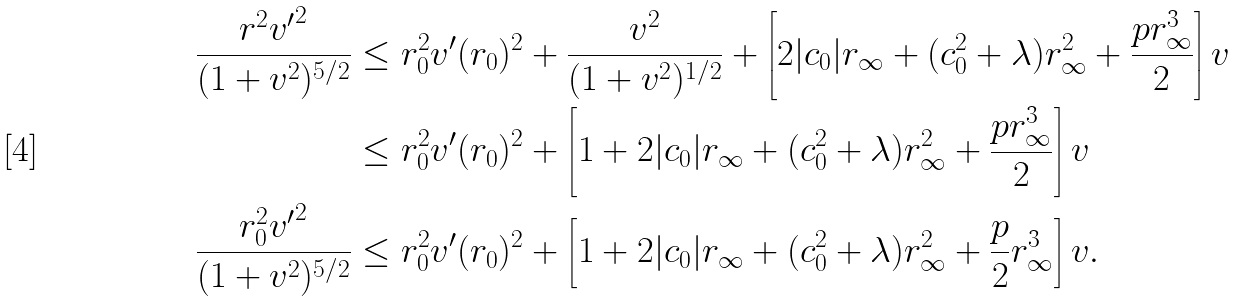Convert formula to latex. <formula><loc_0><loc_0><loc_500><loc_500>\frac { r ^ { 2 } { v ^ { \prime } } ^ { 2 } } { ( 1 + v ^ { 2 } ) ^ { 5 / 2 } } & \leq r _ { 0 } ^ { 2 } v ^ { \prime } ( r _ { 0 } ) ^ { 2 } + \frac { v ^ { 2 } } { ( 1 + v ^ { 2 } ) ^ { 1 / 2 } } + \left [ 2 | c _ { 0 } | r _ { \infty } + ( c _ { 0 } ^ { 2 } + \lambda ) r _ { \infty } ^ { 2 } + \frac { p r _ { \infty } ^ { 3 } } { 2 } \right ] v \\ & \leq r _ { 0 } ^ { 2 } v ^ { \prime } ( r _ { 0 } ) ^ { 2 } + \left [ 1 + 2 | c _ { 0 } | r _ { \infty } + ( c _ { 0 } ^ { 2 } + \lambda ) r _ { \infty } ^ { 2 } + \frac { p r _ { \infty } ^ { 3 } } { 2 } \right ] v \\ \frac { r _ { 0 } ^ { 2 } { v ^ { \prime } } ^ { 2 } } { ( 1 + v ^ { 2 } ) ^ { 5 / 2 } } & \leq r _ { 0 } ^ { 2 } v ^ { \prime } ( r _ { 0 } ) ^ { 2 } + \left [ 1 + 2 | c _ { 0 } | r _ { \infty } + ( c _ { 0 } ^ { 2 } + \lambda ) r _ { \infty } ^ { 2 } + \frac { p } { 2 } r _ { \infty } ^ { 3 } \right ] v .</formula> 